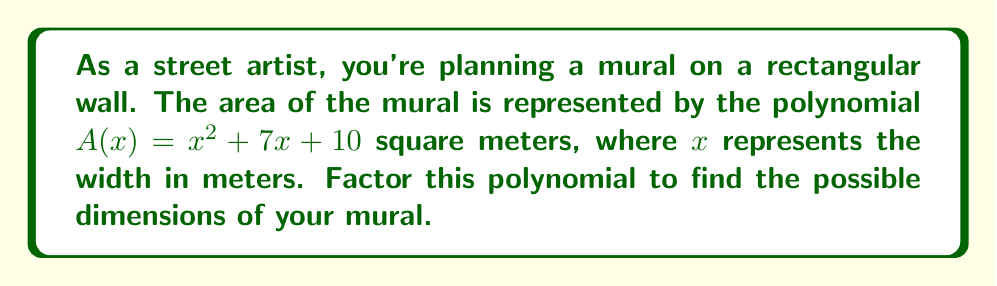Could you help me with this problem? To factor the polynomial $A(x) = x^2 + 7x + 10$, we'll use the following steps:

1) First, identify that this is a quadratic polynomial in the form $ax^2 + bx + c$, where $a=1$, $b=7$, and $c=10$.

2) We need to find two numbers that multiply to give $ac = 1 \times 10 = 10$ and add up to $b = 7$.

3) The numbers that satisfy this are 2 and 5, as $2 \times 5 = 10$ and $2 + 5 = 7$.

4) Rewrite the middle term using these numbers:
   $A(x) = x^2 + 2x + 5x + 10$

5) Group the terms:
   $A(x) = (x^2 + 2x) + (5x + 10)$

6) Factor out the common factor from each group:
   $A(x) = x(x + 2) + 5(x + 2)$

7) Factor out the common binomial $(x + 2)$:
   $A(x) = (x + 5)(x + 2)$

Therefore, the factored form of the polynomial is $(x + 5)(x + 2)$.

In the context of the mural, this means:
- Width = $x$ meters
- Length = $(x + 5)$ meters or $(x + 2)$ meters

The dimensions of the mural could be $x$ by $(x + 5)$ meters or $x$ by $(x + 2)$ meters.
Answer: $(x + 5)(x + 2)$ 